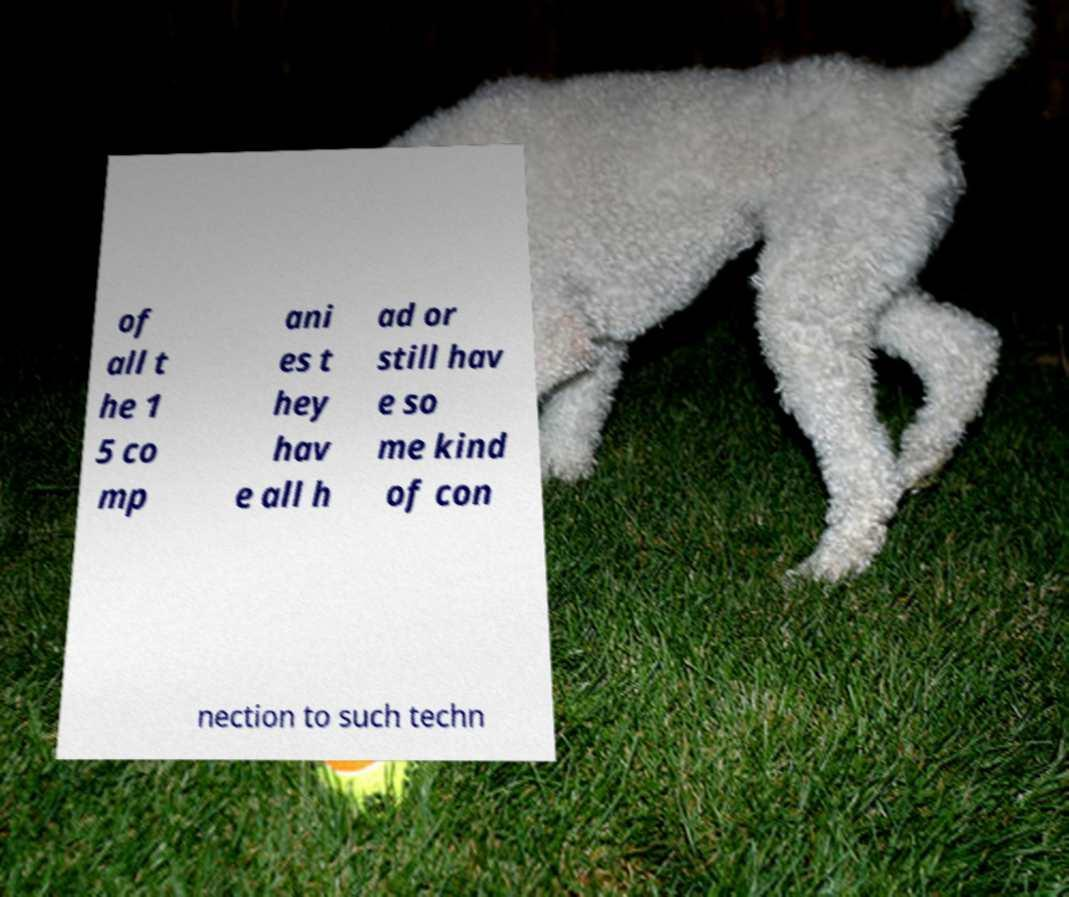Please identify and transcribe the text found in this image. of all t he 1 5 co mp ani es t hey hav e all h ad or still hav e so me kind of con nection to such techn 